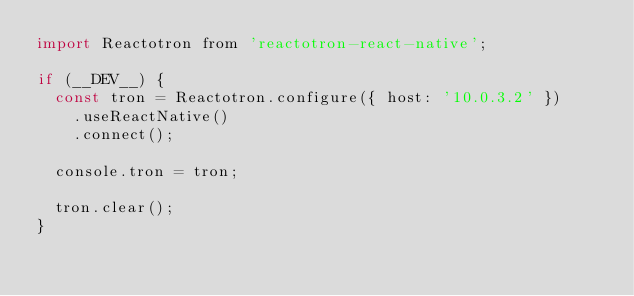<code> <loc_0><loc_0><loc_500><loc_500><_JavaScript_>import Reactotron from 'reactotron-react-native';

if (__DEV__) {
  const tron = Reactotron.configure({ host: '10.0.3.2' })
    .useReactNative()
    .connect();

  console.tron = tron;

  tron.clear();
}
</code> 